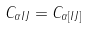Convert formula to latex. <formula><loc_0><loc_0><loc_500><loc_500>C _ { \alpha I J } = C _ { \alpha [ I J ] }</formula> 